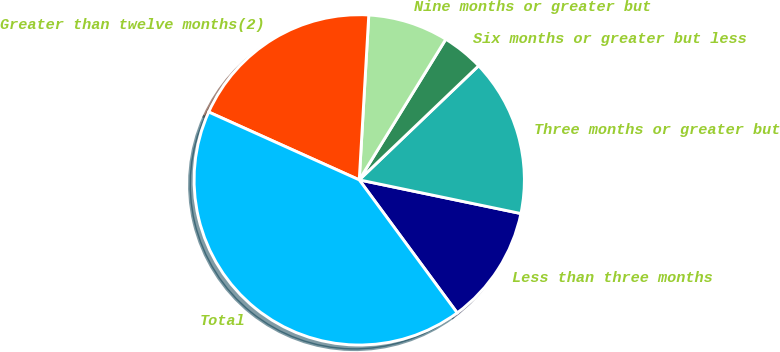Convert chart to OTSL. <chart><loc_0><loc_0><loc_500><loc_500><pie_chart><fcel>Less than three months<fcel>Three months or greater but<fcel>Six months or greater but less<fcel>Nine months or greater but<fcel>Greater than twelve months(2)<fcel>Total<nl><fcel>11.63%<fcel>15.41%<fcel>4.08%<fcel>7.86%<fcel>19.18%<fcel>41.84%<nl></chart> 